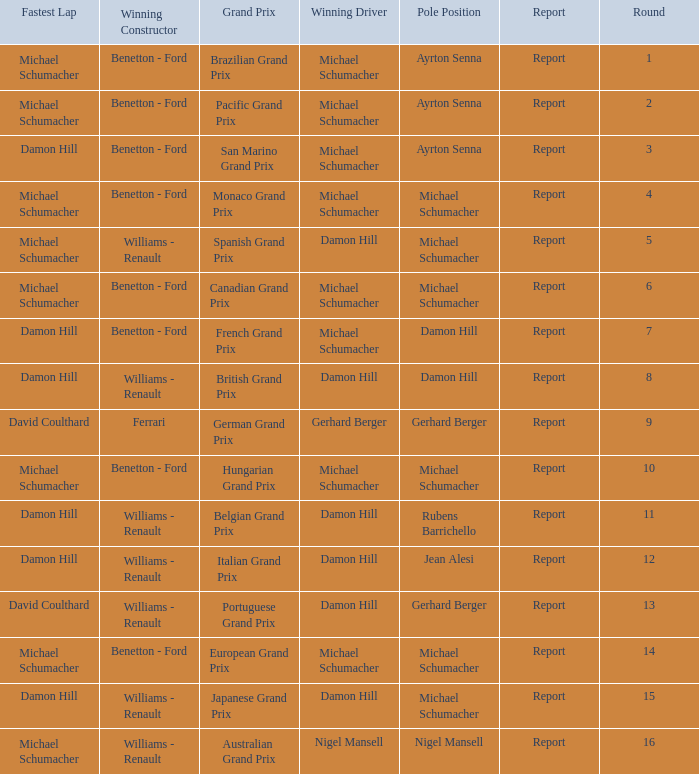Name the fastest lap for the brazilian grand prix Michael Schumacher. 